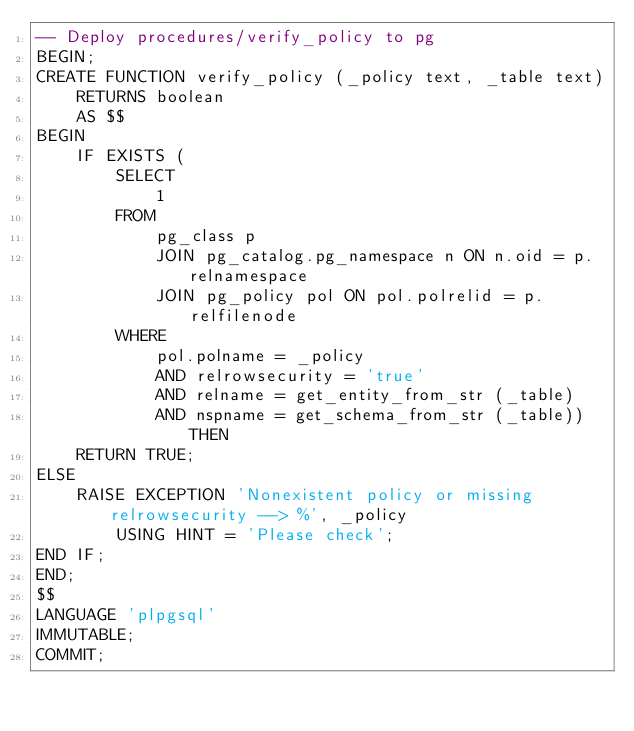Convert code to text. <code><loc_0><loc_0><loc_500><loc_500><_SQL_>-- Deploy procedures/verify_policy to pg
BEGIN;
CREATE FUNCTION verify_policy (_policy text, _table text)
    RETURNS boolean
    AS $$
BEGIN
    IF EXISTS (
        SELECT
            1
        FROM
            pg_class p
            JOIN pg_catalog.pg_namespace n ON n.oid = p.relnamespace
            JOIN pg_policy pol ON pol.polrelid = p.relfilenode
        WHERE
            pol.polname = _policy
            AND relrowsecurity = 'true'
            AND relname = get_entity_from_str (_table)
            AND nspname = get_schema_from_str (_table)) THEN
    RETURN TRUE;
ELSE
    RAISE EXCEPTION 'Nonexistent policy or missing relrowsecurity --> %', _policy
        USING HINT = 'Please check';
END IF;
END;
$$
LANGUAGE 'plpgsql'
IMMUTABLE;
COMMIT;

</code> 